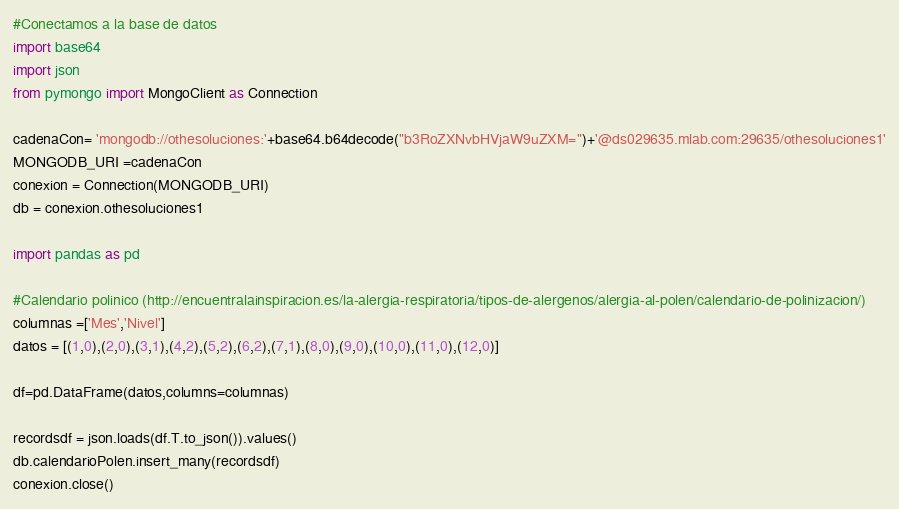Convert code to text. <code><loc_0><loc_0><loc_500><loc_500><_Python_>#Conectamos a la base de datos
import base64
import json
from pymongo import MongoClient as Connection

cadenaCon= 'mongodb://othesoluciones:'+base64.b64decode("b3RoZXNvbHVjaW9uZXM=")+'@ds029635.mlab.com:29635/othesoluciones1'
MONGODB_URI =cadenaCon
conexion = Connection(MONGODB_URI)
db = conexion.othesoluciones1

import pandas as pd

#Calendario polinico (http://encuentralainspiracion.es/la-alergia-respiratoria/tipos-de-alergenos/alergia-al-polen/calendario-de-polinizacion/)
columnas =['Mes','Nivel']
datos = [(1,0),(2,0),(3,1),(4,2),(5,2),(6,2),(7,1),(8,0),(9,0),(10,0),(11,0),(12,0)]

df=pd.DataFrame(datos,columns=columnas)

recordsdf = json.loads(df.T.to_json()).values()
db.calendarioPolen.insert_many(recordsdf)
conexion.close()</code> 